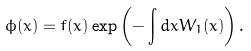<formula> <loc_0><loc_0><loc_500><loc_500>\phi ( x ) = f ( x ) \exp \left ( - \int d x W _ { 1 } ( x ) \right ) .</formula> 